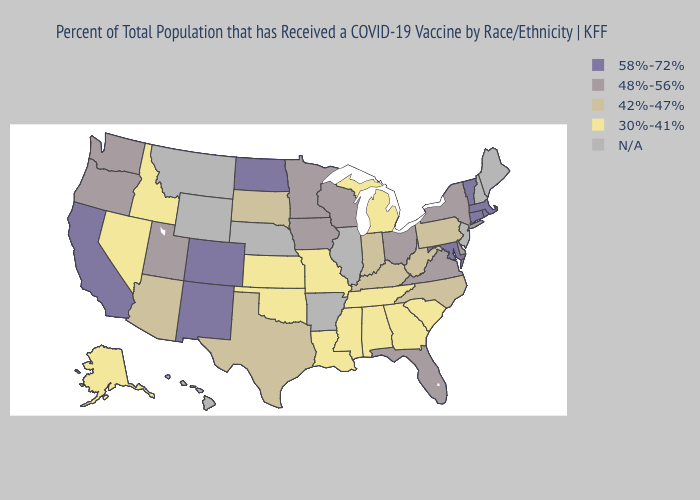Name the states that have a value in the range 48%-56%?
Be succinct. Delaware, Florida, Iowa, Minnesota, New York, Ohio, Oregon, Utah, Virginia, Washington, Wisconsin. Among the states that border Michigan , does Indiana have the lowest value?
Short answer required. Yes. Name the states that have a value in the range 42%-47%?
Short answer required. Arizona, Indiana, Kentucky, North Carolina, Pennsylvania, South Dakota, Texas, West Virginia. What is the highest value in the USA?
Be succinct. 58%-72%. What is the highest value in the USA?
Short answer required. 58%-72%. Name the states that have a value in the range 58%-72%?
Be succinct. California, Colorado, Connecticut, Maryland, Massachusetts, New Mexico, North Dakota, Rhode Island, Vermont. Does the first symbol in the legend represent the smallest category?
Concise answer only. No. What is the value of Maine?
Write a very short answer. N/A. Which states hav the highest value in the Northeast?
Keep it brief. Connecticut, Massachusetts, Rhode Island, Vermont. What is the lowest value in states that border Kansas?
Concise answer only. 30%-41%. What is the lowest value in states that border Texas?
Answer briefly. 30%-41%. What is the highest value in the South ?
Quick response, please. 58%-72%. Name the states that have a value in the range 58%-72%?
Give a very brief answer. California, Colorado, Connecticut, Maryland, Massachusetts, New Mexico, North Dakota, Rhode Island, Vermont. Among the states that border Massachusetts , does Connecticut have the highest value?
Write a very short answer. Yes. 